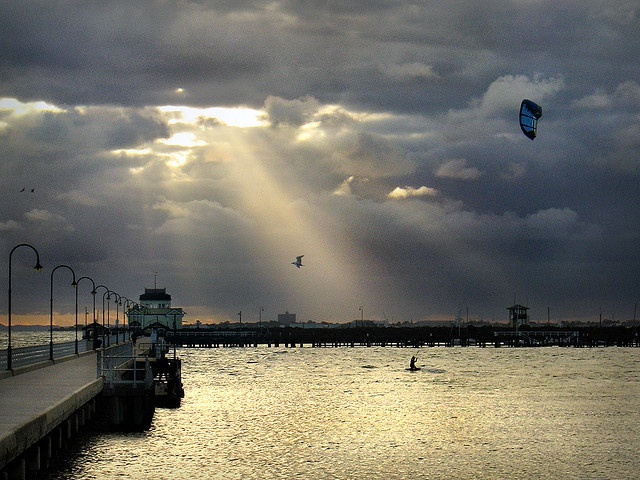Describe the objects in this image and their specific colors. I can see kite in gray, black, blue, and navy tones, bird in gray and black tones, people in gray, black, darkgreen, and olive tones, people in black and gray tones, and surfboard in gray, black, and darkgreen tones in this image. 